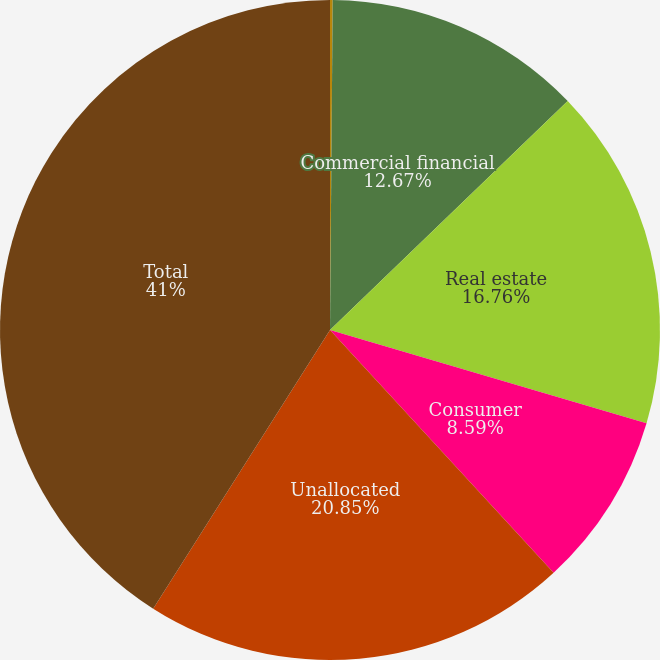<chart> <loc_0><loc_0><loc_500><loc_500><pie_chart><fcel>December 31<fcel>Commercial financial<fcel>Real estate<fcel>Consumer<fcel>Unallocated<fcel>Total<nl><fcel>0.13%<fcel>12.67%<fcel>16.76%<fcel>8.59%<fcel>20.85%<fcel>41.0%<nl></chart> 